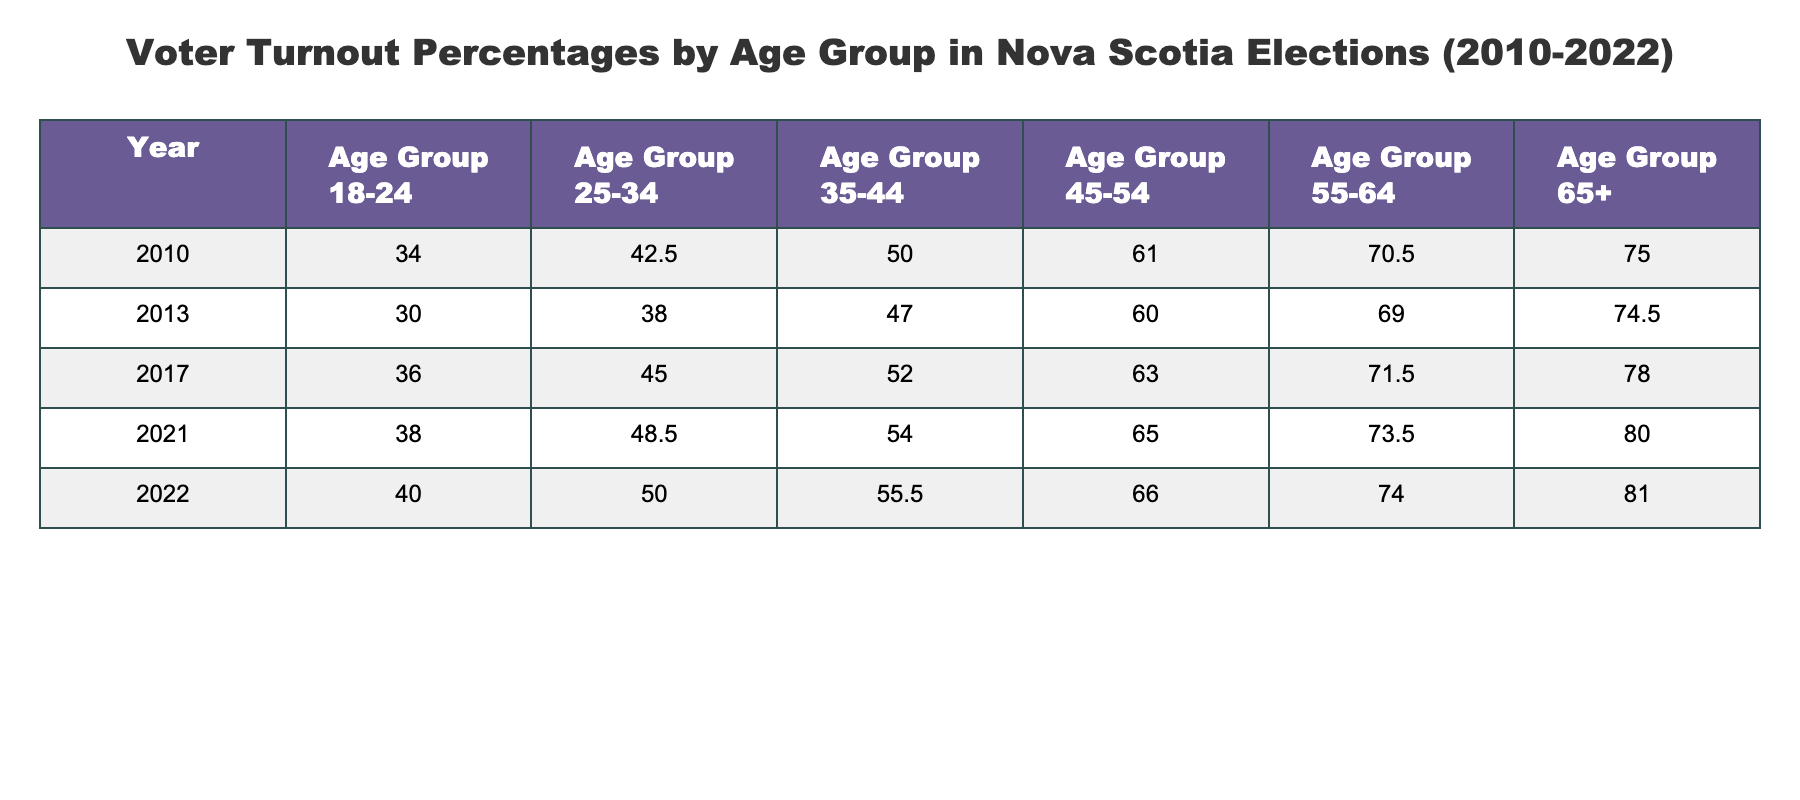What was the voter turnout percentage for the 18-24 age group in 2010? According to the table, the voter turnout percentage for the 18-24 age group in 2010 is listed directly in the row for that year, which shows a value of 34.0.
Answer: 34.0 What age group had the highest voter turnout in 2022? By looking at the 2022 row, the highest voter turnout percentage is found in the 65+ age group, which has a turnout of 81.0.
Answer: 65+ What was the increase in voter turnout for the 25-34 age group from 2010 to 2022? The 25-34 age group had a turnout of 42.5 in 2010 and 50.0 in 2022. The increase is calculated as 50.0 - 42.5 = 7.5.
Answer: 7.5 Did voter turnout for the 45-54 age group ever exceed 65% from 2010 to 2022? By checking the percentages for the 45-54 age group across all years, we see that it was 61.0 in 2010 and rose to 66.0 in 2022, indicating that it did exceed 65% starting in 2022.
Answer: Yes What was the average voter turnout for the 35-44 age group over all years? To find the average, we sum the percentages for the 35-44 age group: (50.0 + 47.0 + 52.0 + 54.0 + 55.5) = 258.5. There are 5 data points, so we divide by 5 to find the average: 258.5 / 5 = 51.7.
Answer: 51.7 